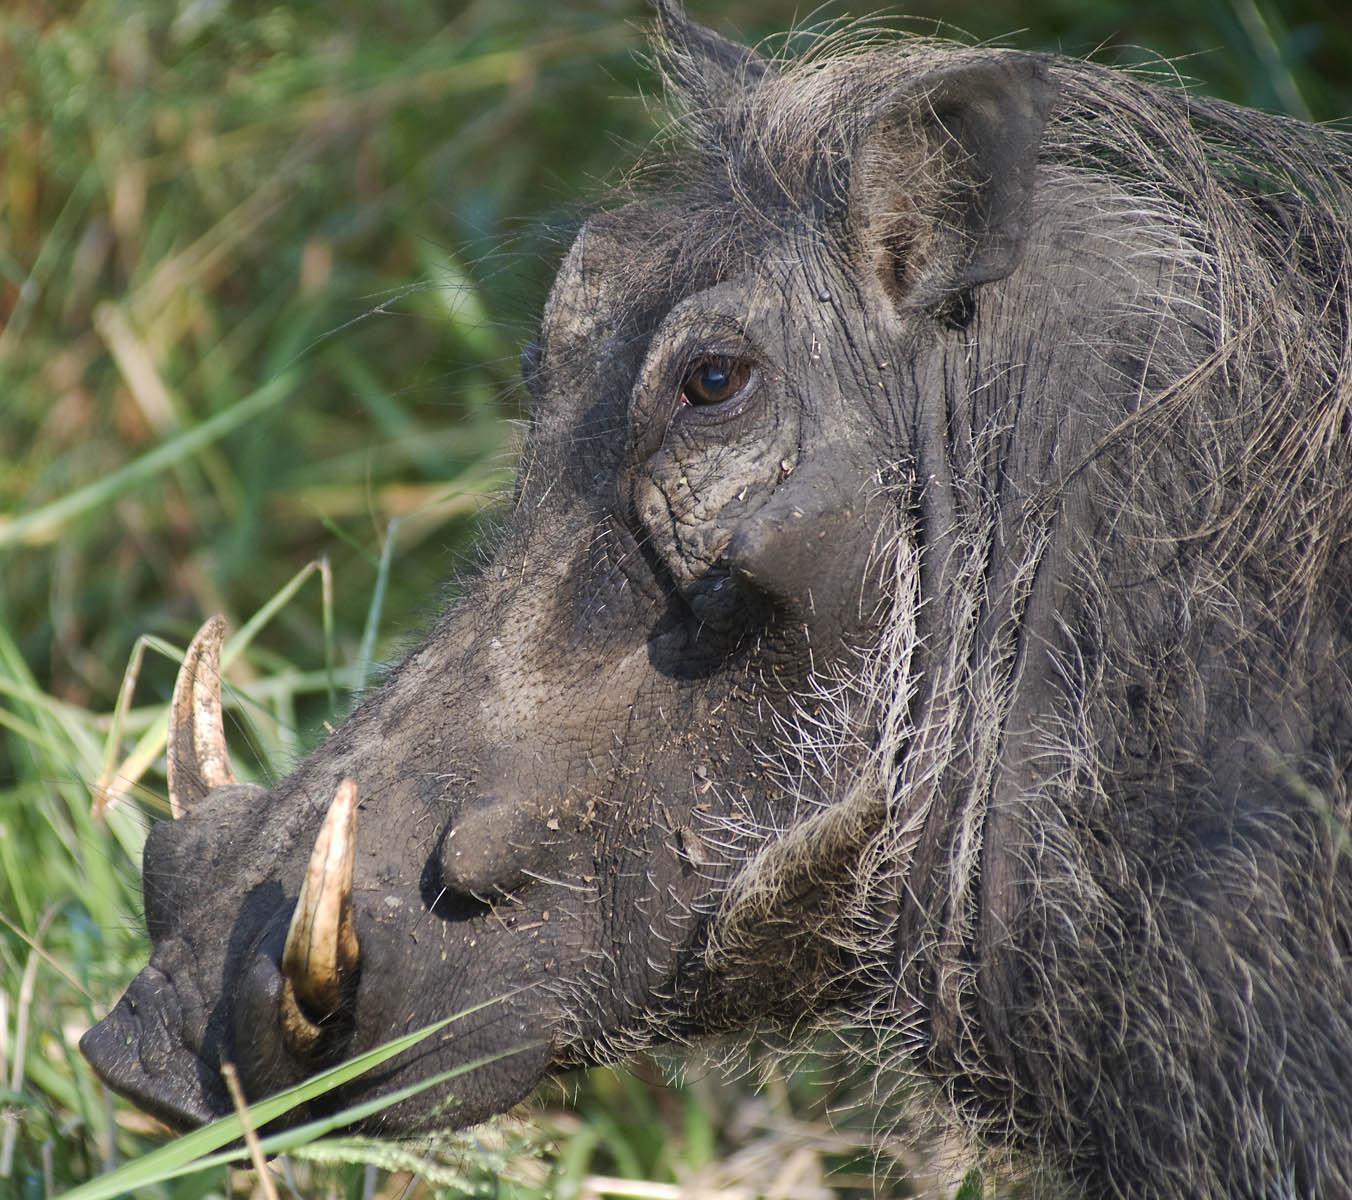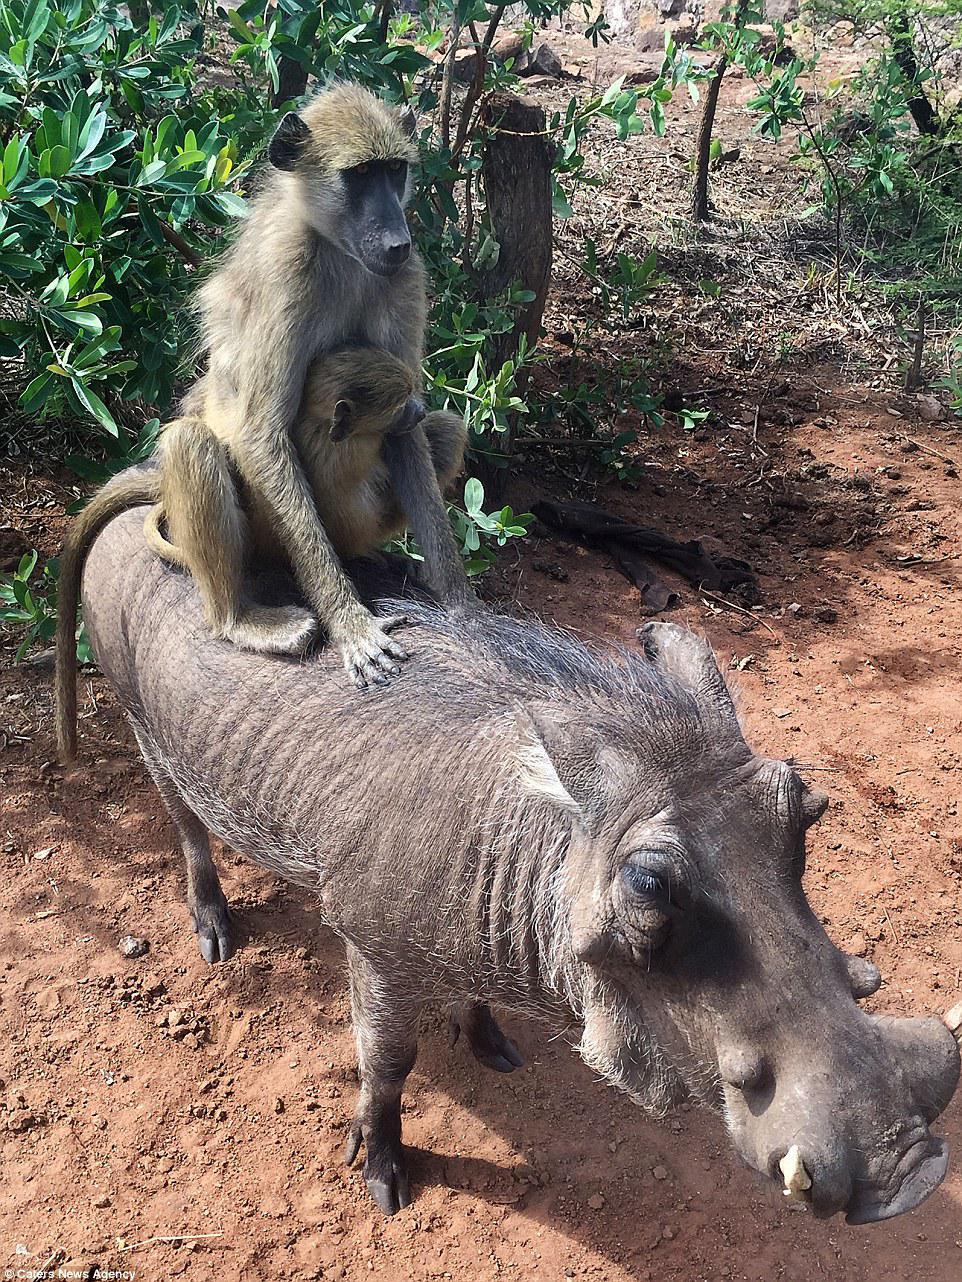The first image is the image on the left, the second image is the image on the right. Evaluate the accuracy of this statement regarding the images: "The only animals shown are exactly two warthogs, in total.". Is it true? Answer yes or no. No. 